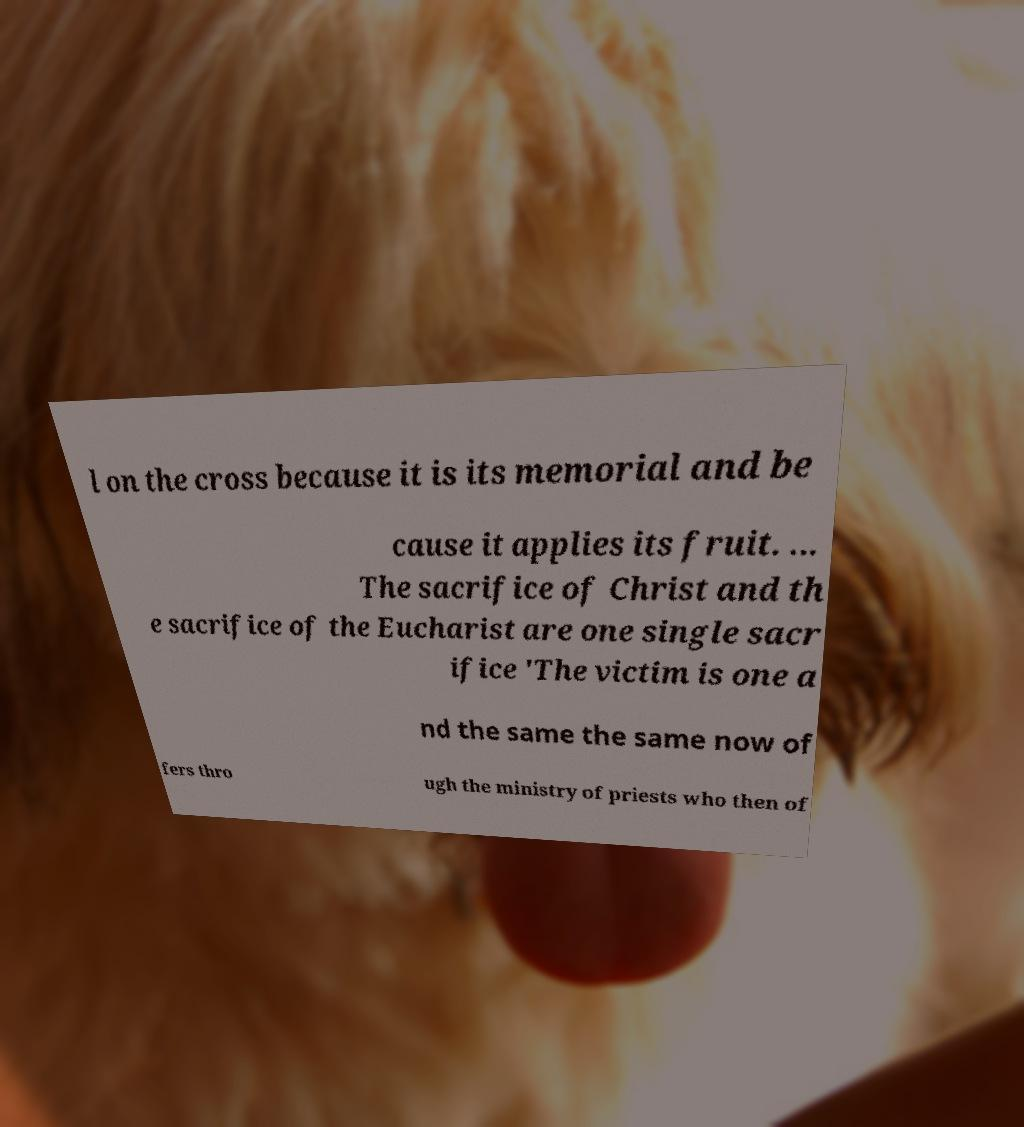Please read and relay the text visible in this image. What does it say? l on the cross because it is its memorial and be cause it applies its fruit. ... The sacrifice of Christ and th e sacrifice of the Eucharist are one single sacr ifice 'The victim is one a nd the same the same now of fers thro ugh the ministry of priests who then of 